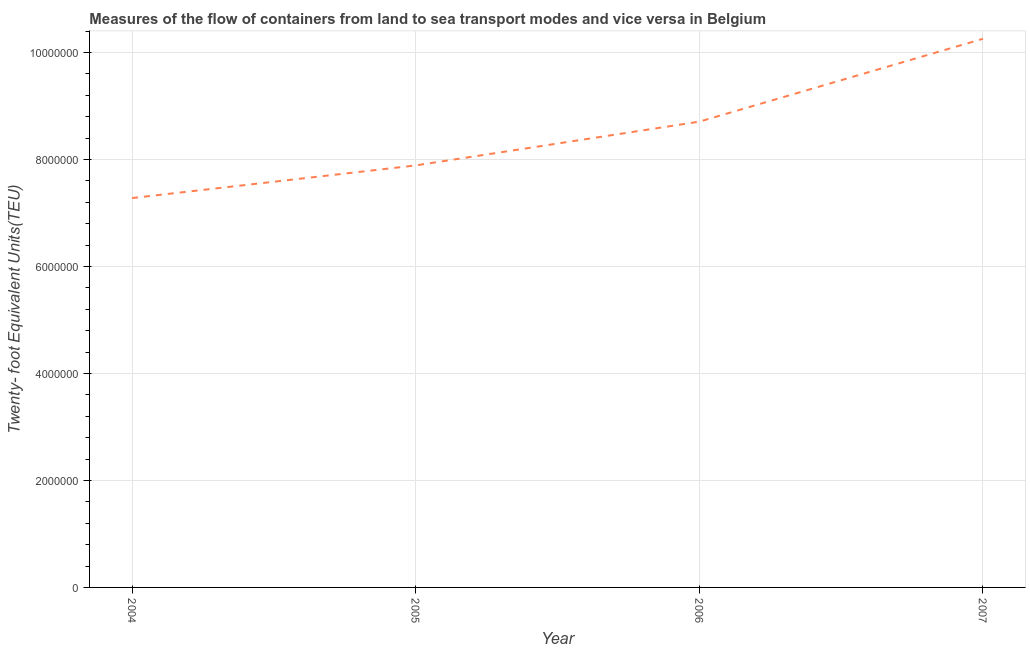What is the container port traffic in 2006?
Provide a short and direct response. 8.71e+06. Across all years, what is the maximum container port traffic?
Your response must be concise. 1.03e+07. Across all years, what is the minimum container port traffic?
Give a very brief answer. 7.28e+06. In which year was the container port traffic maximum?
Offer a very short reply. 2007. What is the sum of the container port traffic?
Keep it short and to the point. 3.41e+07. What is the difference between the container port traffic in 2005 and 2007?
Make the answer very short. -2.37e+06. What is the average container port traffic per year?
Provide a succinct answer. 8.53e+06. What is the median container port traffic?
Ensure brevity in your answer.  8.30e+06. What is the ratio of the container port traffic in 2004 to that in 2007?
Your response must be concise. 0.71. Is the container port traffic in 2004 less than that in 2006?
Your answer should be very brief. Yes. What is the difference between the highest and the second highest container port traffic?
Provide a short and direct response. 1.55e+06. What is the difference between the highest and the lowest container port traffic?
Ensure brevity in your answer.  2.98e+06. How many lines are there?
Make the answer very short. 1. How many years are there in the graph?
Keep it short and to the point. 4. Does the graph contain any zero values?
Make the answer very short. No. What is the title of the graph?
Offer a terse response. Measures of the flow of containers from land to sea transport modes and vice versa in Belgium. What is the label or title of the X-axis?
Give a very brief answer. Year. What is the label or title of the Y-axis?
Your answer should be compact. Twenty- foot Equivalent Units(TEU). What is the Twenty- foot Equivalent Units(TEU) of 2004?
Your response must be concise. 7.28e+06. What is the Twenty- foot Equivalent Units(TEU) in 2005?
Make the answer very short. 7.89e+06. What is the Twenty- foot Equivalent Units(TEU) in 2006?
Give a very brief answer. 8.71e+06. What is the Twenty- foot Equivalent Units(TEU) in 2007?
Offer a very short reply. 1.03e+07. What is the difference between the Twenty- foot Equivalent Units(TEU) in 2004 and 2005?
Provide a succinct answer. -6.10e+05. What is the difference between the Twenty- foot Equivalent Units(TEU) in 2004 and 2006?
Offer a terse response. -1.43e+06. What is the difference between the Twenty- foot Equivalent Units(TEU) in 2004 and 2007?
Make the answer very short. -2.98e+06. What is the difference between the Twenty- foot Equivalent Units(TEU) in 2005 and 2006?
Your answer should be very brief. -8.18e+05. What is the difference between the Twenty- foot Equivalent Units(TEU) in 2005 and 2007?
Offer a terse response. -2.37e+06. What is the difference between the Twenty- foot Equivalent Units(TEU) in 2006 and 2007?
Keep it short and to the point. -1.55e+06. What is the ratio of the Twenty- foot Equivalent Units(TEU) in 2004 to that in 2005?
Provide a succinct answer. 0.92. What is the ratio of the Twenty- foot Equivalent Units(TEU) in 2004 to that in 2006?
Your answer should be very brief. 0.84. What is the ratio of the Twenty- foot Equivalent Units(TEU) in 2004 to that in 2007?
Offer a very short reply. 0.71. What is the ratio of the Twenty- foot Equivalent Units(TEU) in 2005 to that in 2006?
Your answer should be very brief. 0.91. What is the ratio of the Twenty- foot Equivalent Units(TEU) in 2005 to that in 2007?
Keep it short and to the point. 0.77. What is the ratio of the Twenty- foot Equivalent Units(TEU) in 2006 to that in 2007?
Offer a very short reply. 0.85. 